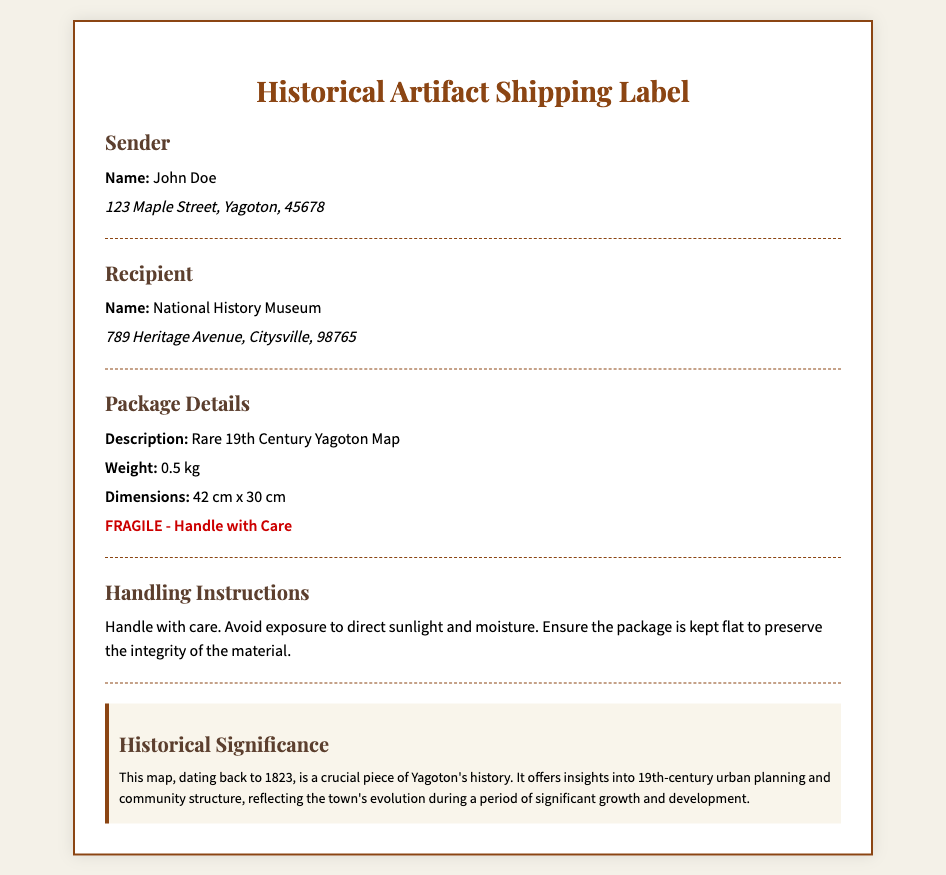What is the sender's name? The sender's name is explicitly mentioned in the document.
Answer: John Doe What is the recipient's address? The complete address of the recipient is provided in the document.
Answer: 789 Heritage Avenue, Citysville, 98765 What is the weight of the package? The weight of the package is included in the package details section.
Answer: 0.5 kg What year does the map date back to? The historical significance section states the year the map originates from.
Answer: 1823 What should be avoided to protect the artifact? The handling instructions warn against a specific condition that could harm the artifact.
Answer: Direct sunlight What is the document primarily about? The title of the document gives a clear indication of its purpose.
Answer: Historical Artifact Shipping Label What is the size of the map? The package details section includes the dimensions of the map.
Answer: 42 cm x 30 cm What color is the warning text? The document specifies the color for the warning indicating the fragility of the package.
Answer: Red 